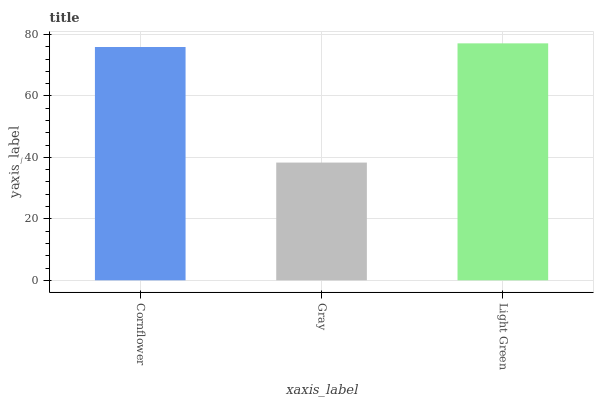Is Gray the minimum?
Answer yes or no. Yes. Is Light Green the maximum?
Answer yes or no. Yes. Is Light Green the minimum?
Answer yes or no. No. Is Gray the maximum?
Answer yes or no. No. Is Light Green greater than Gray?
Answer yes or no. Yes. Is Gray less than Light Green?
Answer yes or no. Yes. Is Gray greater than Light Green?
Answer yes or no. No. Is Light Green less than Gray?
Answer yes or no. No. Is Cornflower the high median?
Answer yes or no. Yes. Is Cornflower the low median?
Answer yes or no. Yes. Is Gray the high median?
Answer yes or no. No. Is Gray the low median?
Answer yes or no. No. 